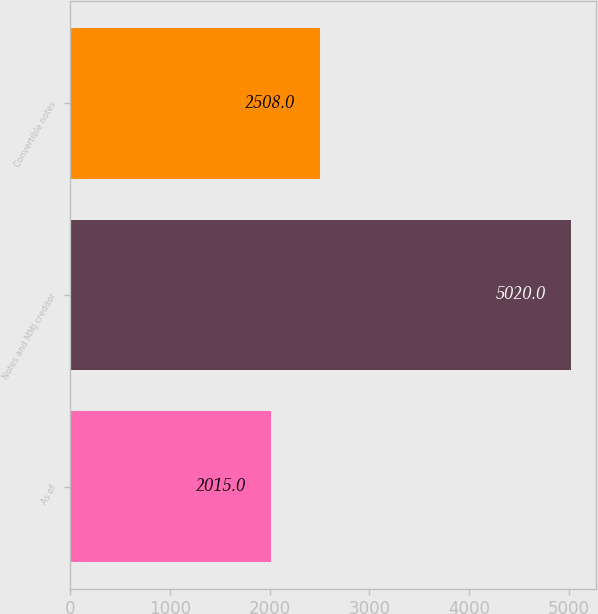Convert chart to OTSL. <chart><loc_0><loc_0><loc_500><loc_500><bar_chart><fcel>As of<fcel>Notes and MMJ creditor<fcel>Convertible notes<nl><fcel>2015<fcel>5020<fcel>2508<nl></chart> 